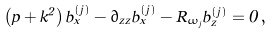Convert formula to latex. <formula><loc_0><loc_0><loc_500><loc_500>\left ( p + k ^ { 2 } \right ) b _ { x } ^ { ( j ) } - \partial _ { z z } b _ { x } ^ { ( j ) } - R _ { \omega _ { j } } b _ { z } ^ { ( j ) } = 0 \, ,</formula> 